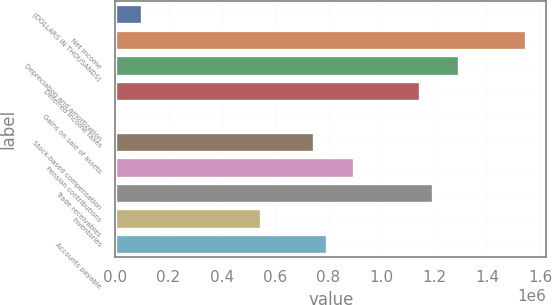Convert chart. <chart><loc_0><loc_0><loc_500><loc_500><bar_chart><fcel>(DOLLARS IN THOUSANDS)<fcel>Net income<fcel>Depreciation and amortization<fcel>Deferred income taxes<fcel>Gains on sale of assets<fcel>Stock-based compensation<fcel>Pension contributions<fcel>Trade receivables<fcel>Inventories<fcel>Accounts payable<nl><fcel>99797.2<fcel>1.54419e+06<fcel>1.29516e+06<fcel>1.14574e+06<fcel>184<fcel>747283<fcel>896703<fcel>1.19554e+06<fcel>548057<fcel>797090<nl></chart> 